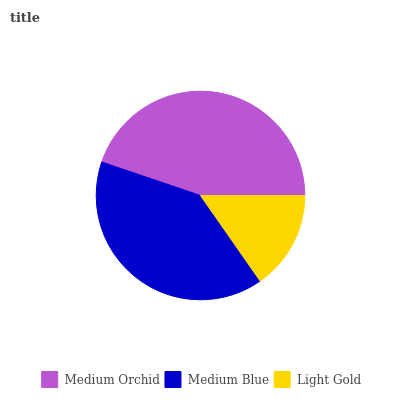Is Light Gold the minimum?
Answer yes or no. Yes. Is Medium Orchid the maximum?
Answer yes or no. Yes. Is Medium Blue the minimum?
Answer yes or no. No. Is Medium Blue the maximum?
Answer yes or no. No. Is Medium Orchid greater than Medium Blue?
Answer yes or no. Yes. Is Medium Blue less than Medium Orchid?
Answer yes or no. Yes. Is Medium Blue greater than Medium Orchid?
Answer yes or no. No. Is Medium Orchid less than Medium Blue?
Answer yes or no. No. Is Medium Blue the high median?
Answer yes or no. Yes. Is Medium Blue the low median?
Answer yes or no. Yes. Is Light Gold the high median?
Answer yes or no. No. Is Medium Orchid the low median?
Answer yes or no. No. 